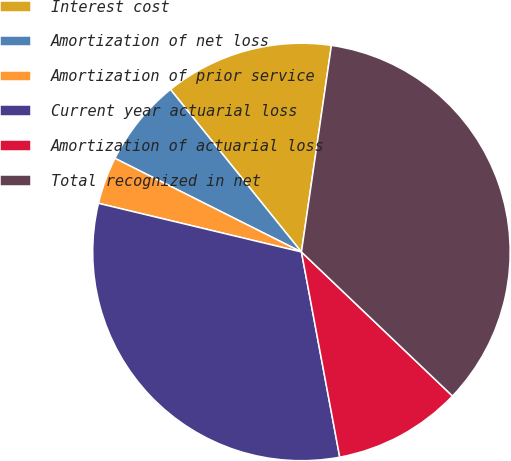<chart> <loc_0><loc_0><loc_500><loc_500><pie_chart><fcel>Interest cost<fcel>Amortization of net loss<fcel>Amortization of prior service<fcel>Current year actuarial loss<fcel>Amortization of actuarial loss<fcel>Total recognized in net<nl><fcel>13.09%<fcel>6.8%<fcel>3.66%<fcel>31.68%<fcel>9.94%<fcel>34.83%<nl></chart> 